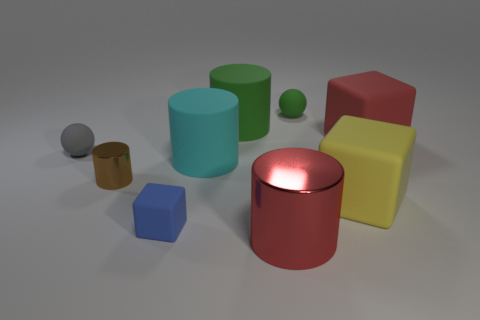There is a object that is on the left side of the blue matte cube and behind the small cylinder; what is its material?
Make the answer very short. Rubber. Do the small gray object and the red matte thing have the same shape?
Offer a very short reply. No. Are there any other things that have the same size as the green sphere?
Provide a succinct answer. Yes. There is a large green cylinder; how many small brown metal cylinders are on the right side of it?
Ensure brevity in your answer.  0. There is a matte block in front of the yellow cube; does it have the same size as the brown shiny object?
Your answer should be very brief. Yes. There is another big matte object that is the same shape as the red matte thing; what color is it?
Provide a short and direct response. Yellow. Is there any other thing that is the same shape as the big metallic thing?
Provide a succinct answer. Yes. There is a object to the left of the brown metallic cylinder; what shape is it?
Ensure brevity in your answer.  Sphere. What number of other cyan objects have the same shape as the big metal object?
Give a very brief answer. 1. Do the big cylinder that is in front of the tiny brown cylinder and the metallic cylinder behind the yellow object have the same color?
Your answer should be very brief. No. 